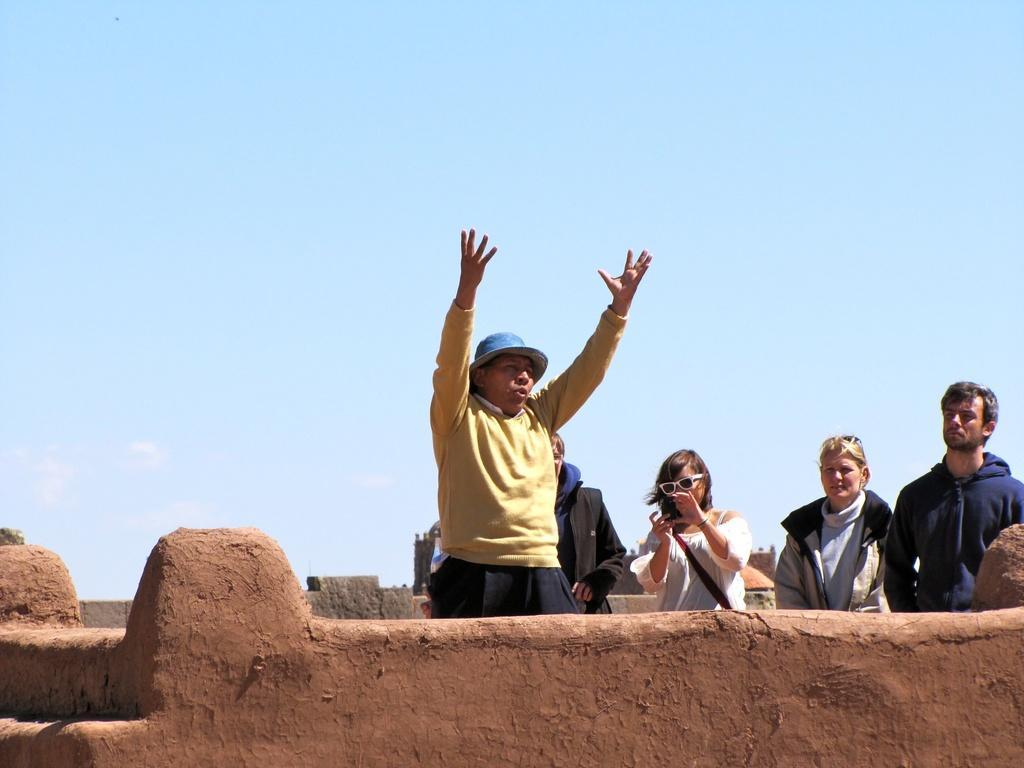Can you describe this image briefly? In this image there are few people at the top of one of the buildings in which one of them holds a mobile phone and the sky. 